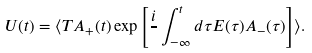<formula> <loc_0><loc_0><loc_500><loc_500>U ( t ) = \langle T A _ { + } ( t ) \exp \left [ \frac { i } { } \int _ { - \infty } ^ { t } d \tau E ( \tau ) A _ { - } ( \tau ) \right ] \rangle .</formula> 